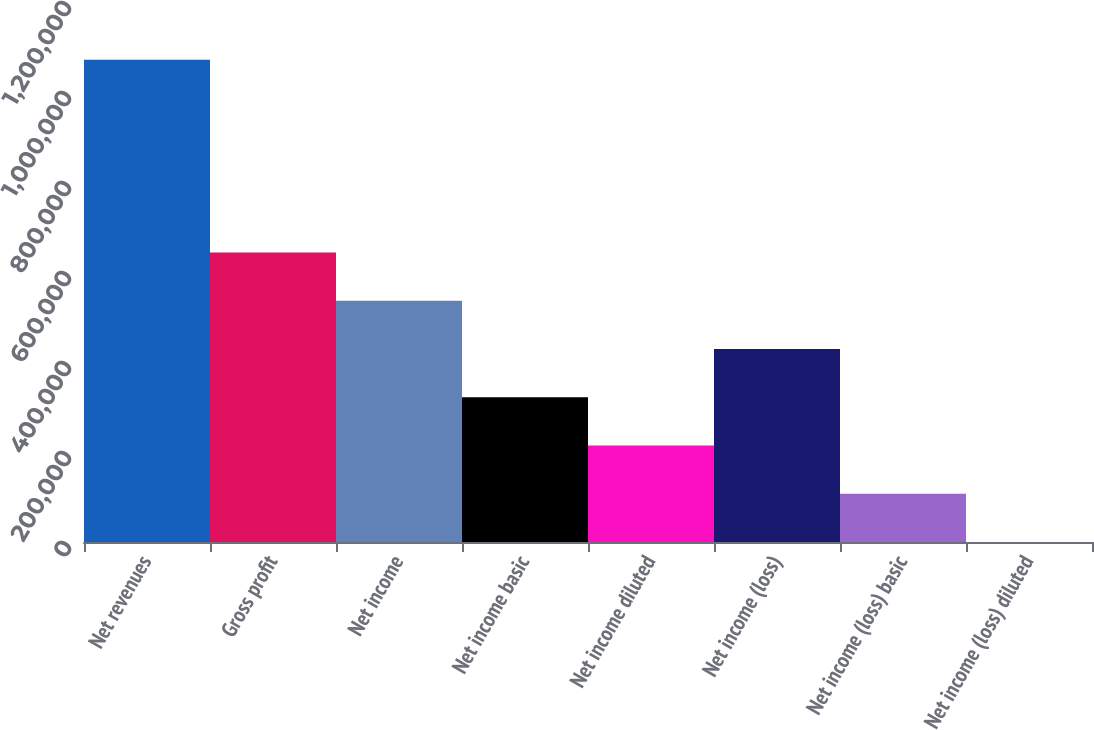Convert chart. <chart><loc_0><loc_0><loc_500><loc_500><bar_chart><fcel>Net revenues<fcel>Gross profit<fcel>Net income<fcel>Net income basic<fcel>Net income diluted<fcel>Net income (loss)<fcel>Net income (loss) basic<fcel>Net income (loss) diluted<nl><fcel>1.07185e+06<fcel>643110<fcel>535925<fcel>321555<fcel>214370<fcel>428740<fcel>107185<fcel>0.56<nl></chart> 